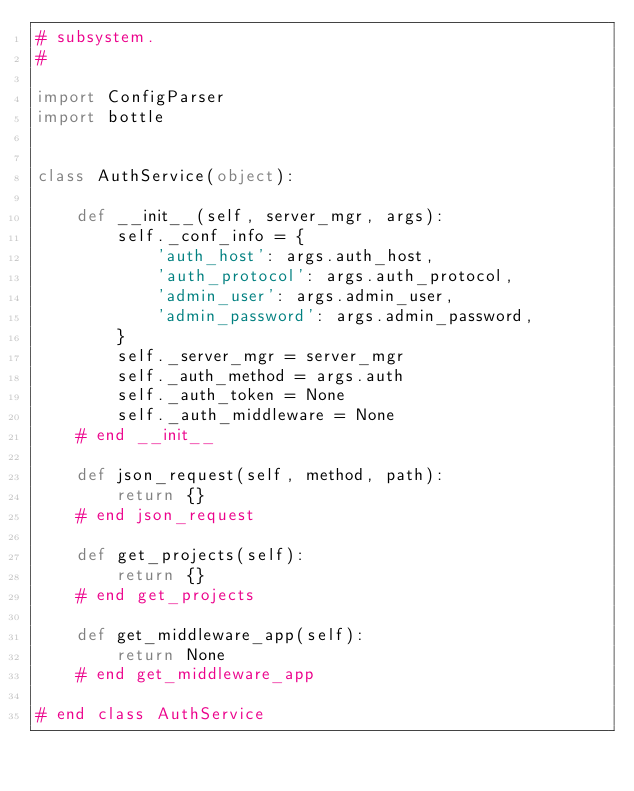<code> <loc_0><loc_0><loc_500><loc_500><_Python_># subsystem.
#

import ConfigParser
import bottle


class AuthService(object):

    def __init__(self, server_mgr, args):
        self._conf_info = {
            'auth_host': args.auth_host,
            'auth_protocol': args.auth_protocol,
            'admin_user': args.admin_user,
            'admin_password': args.admin_password,
        }
        self._server_mgr = server_mgr
        self._auth_method = args.auth
        self._auth_token = None
        self._auth_middleware = None
    # end __init__

    def json_request(self, method, path):
        return {}
    # end json_request

    def get_projects(self):
        return {}
    # end get_projects

    def get_middleware_app(self):
        return None
    # end get_middleware_app

# end class AuthService
</code> 